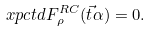<formula> <loc_0><loc_0><loc_500><loc_500>\ x p c t d { F _ { \rho } ^ { R C } ( \vec { t } \alpha ) } = 0 .</formula> 